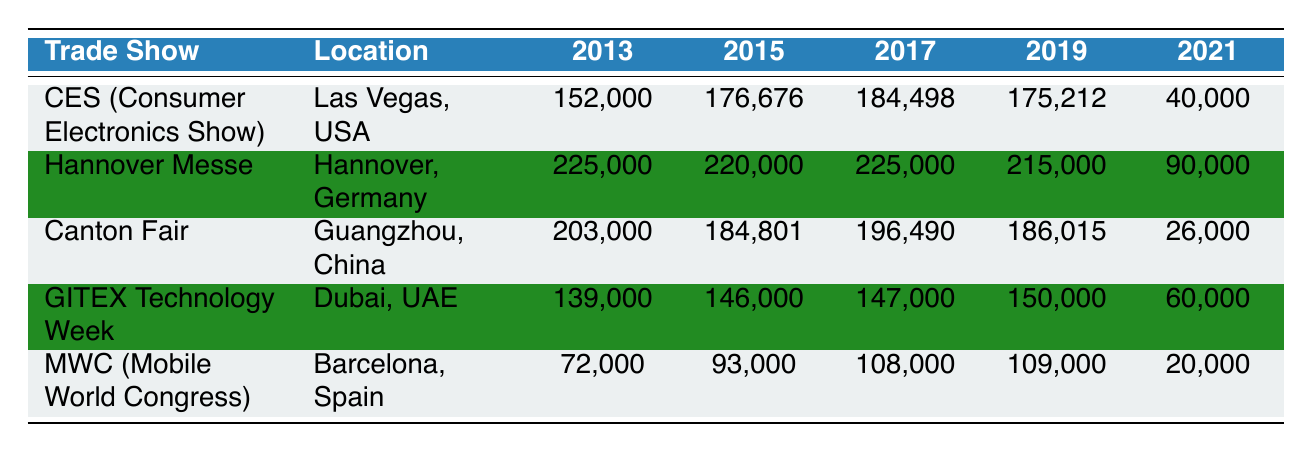What was the attendance for CES in 2019? Looking at the row for CES in the table, the attendance figure listed for the year 2019 is 175,212.
Answer: 175,212 Which trade show had the highest attendance in 2013? The table shows that Hannover Messe had the highest attendance in 2013 with 225,000, compared to the other trade shows listed.
Answer: Hannover Messe What is the percentage decrease in attendance for MWC from 2017 to 2021? MWC had an attendance of 108,000 in 2017 and dropped to 20,000 in 2021. The decrease is 108,000 - 20,000 = 88,000. The percentage decrease is (88,000 / 108,000) * 100 ≈ 81.48%.
Answer: Approximately 81.48% Did GITEX Technology Week have a higher attendance in 2019 than CES in 2021? The attendance for GITEX Technology Week in 2019 is 150,000, while CES had 40,000 in 2021. Since 150,000 > 40,000, the answer is yes.
Answer: Yes What was the average attendance across all trade shows in 2015? In 2015, the attendance figures are 176,676 (CES), 220,000 (Hannover Messe), 184,801 (Canton Fair), 146,000 (GITEX), and 93,000 (MWC). The total attendance is 176,676 + 220,000 + 184,801 + 146,000 + 93,000 = 820,477. The average is 820,477 / 5 = 164,095.4.
Answer: 164,095.4 Which trade show showed the least decrease in attendance between 2013 and 2021? To find the least decrease, calculate the difference from 2013 to 2021 for each trade show. CES: 152,000 - 40,000 = 112,000; Hannover: 225,000 - 90,000 = 135,000; Canton: 203,000 - 26,000 = 177,000; GITEX: 139,000 - 60,000 = 79,000; MWC: 72,000 - 20,000 = 52,000. MWC had the smallest decrease of 52,000.
Answer: MWC How much attendance dropped for Hannover Messe from 2013 to 2019? Hannover Messe had an attendance of 225,000 in 2013 and decreased to 215,000 in 2019. The drop in attendance is 225,000 - 215,000 = 10,000.
Answer: 10,000 Which trade show had higher overall attendance in the 2010s (2013-2019) compared to others? We need to sum the attendance figures for each trade show from 2013 to 2019. For CES: 152,000 + 176,676 + 184,498 + 175,212 = 688,386. For Hannover: 225,000 + 220,000 + 225,000 + 215,000 = 885,000. For Canton: 203,000 + 184,801 + 196,490 + 186,015 = 770,306. For GITEX: 139,000 + 146,000 + 147,000 + 150,000 = 582,000. For MWC: 72,000 + 93,000 + 108,000 + 109,000 = 382,000. The highest is Hannover Messe with 885,000.
Answer: Hannover Messe What was the attendance difference between CES and Canton Fair in 2017? In 2017, CES had an attendance of 184,498, and Canton Fair had 196,490. The difference is 196,490 - 184,498 = 11,992.
Answer: 11,992 